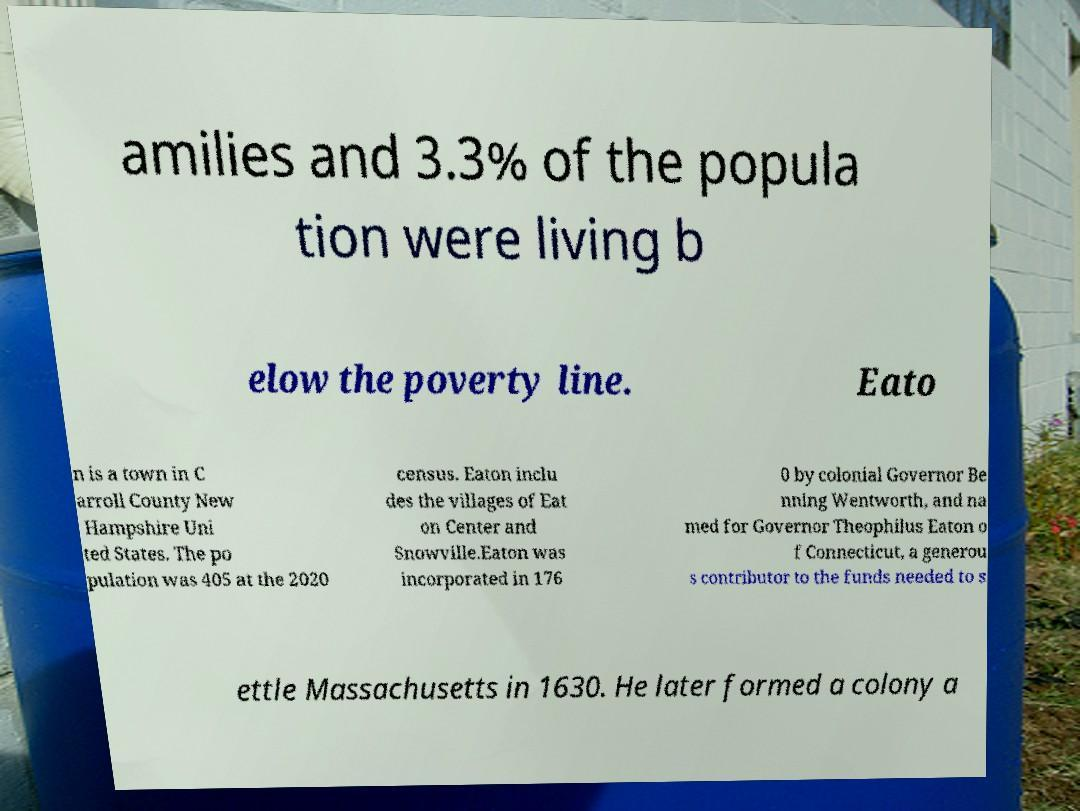There's text embedded in this image that I need extracted. Can you transcribe it verbatim? amilies and 3.3% of the popula tion were living b elow the poverty line. Eato n is a town in C arroll County New Hampshire Uni ted States. The po pulation was 405 at the 2020 census. Eaton inclu des the villages of Eat on Center and Snowville.Eaton was incorporated in 176 0 by colonial Governor Be nning Wentworth, and na med for Governor Theophilus Eaton o f Connecticut, a generou s contributor to the funds needed to s ettle Massachusetts in 1630. He later formed a colony a 